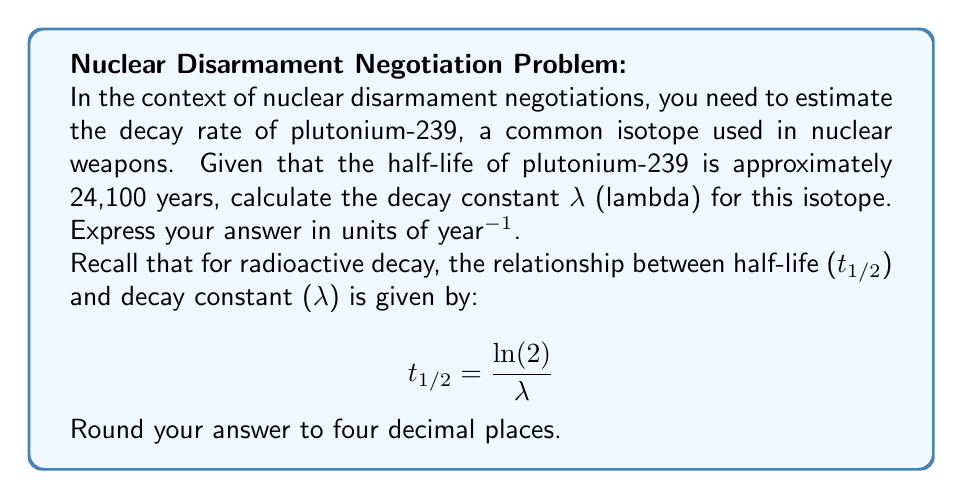Show me your answer to this math problem. To solve this problem, we'll follow these steps:

1) We are given the half-life (t₁/₂) of plutonium-239: 24,100 years.

2) We need to use the equation relating half-life to decay constant:

   $$ t_{1/2} = \frac{\ln(2)}{\lambda} $$

3) Rearrange the equation to solve for λ:

   $$ \lambda = \frac{\ln(2)}{t_{1/2}} $$

4) Substitute the known value:

   $$ \lambda = \frac{\ln(2)}{24,100} $$

5) Calculate:
   
   $$ \lambda = \frac{0.693147...}{24,100} $$

   $$ \lambda \approx 0.0000287614... \text{ year}^{-1} $$

6) Round to four decimal places:

   $$ \lambda \approx 0.0000 \text{ year}^{-1} $$

This decay constant represents the probability per unit time that a given nucleus will decay. In the context of nuclear disarmament, understanding this rate is crucial for estimating the long-term composition and potency of nuclear stockpiles, which can inform arms control negotiations and verification processes.
Answer: $0.0000 \text{ year}^{-1}$ 